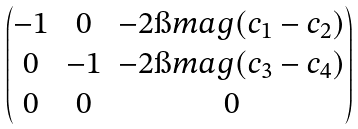<formula> <loc_0><loc_0><loc_500><loc_500>\begin{pmatrix} - 1 & 0 & - 2 \i m a g ( c _ { 1 } - c _ { 2 } ) \\ 0 & - 1 & - 2 \i m a g ( c _ { 3 } - c _ { 4 } ) \\ 0 & 0 & 0 \end{pmatrix}</formula> 